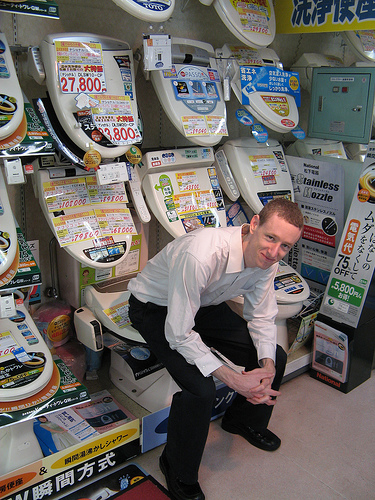What is that boy on? The boy is amusingly positioned on a toilet, which is part of the merchandise displayed in the store. 